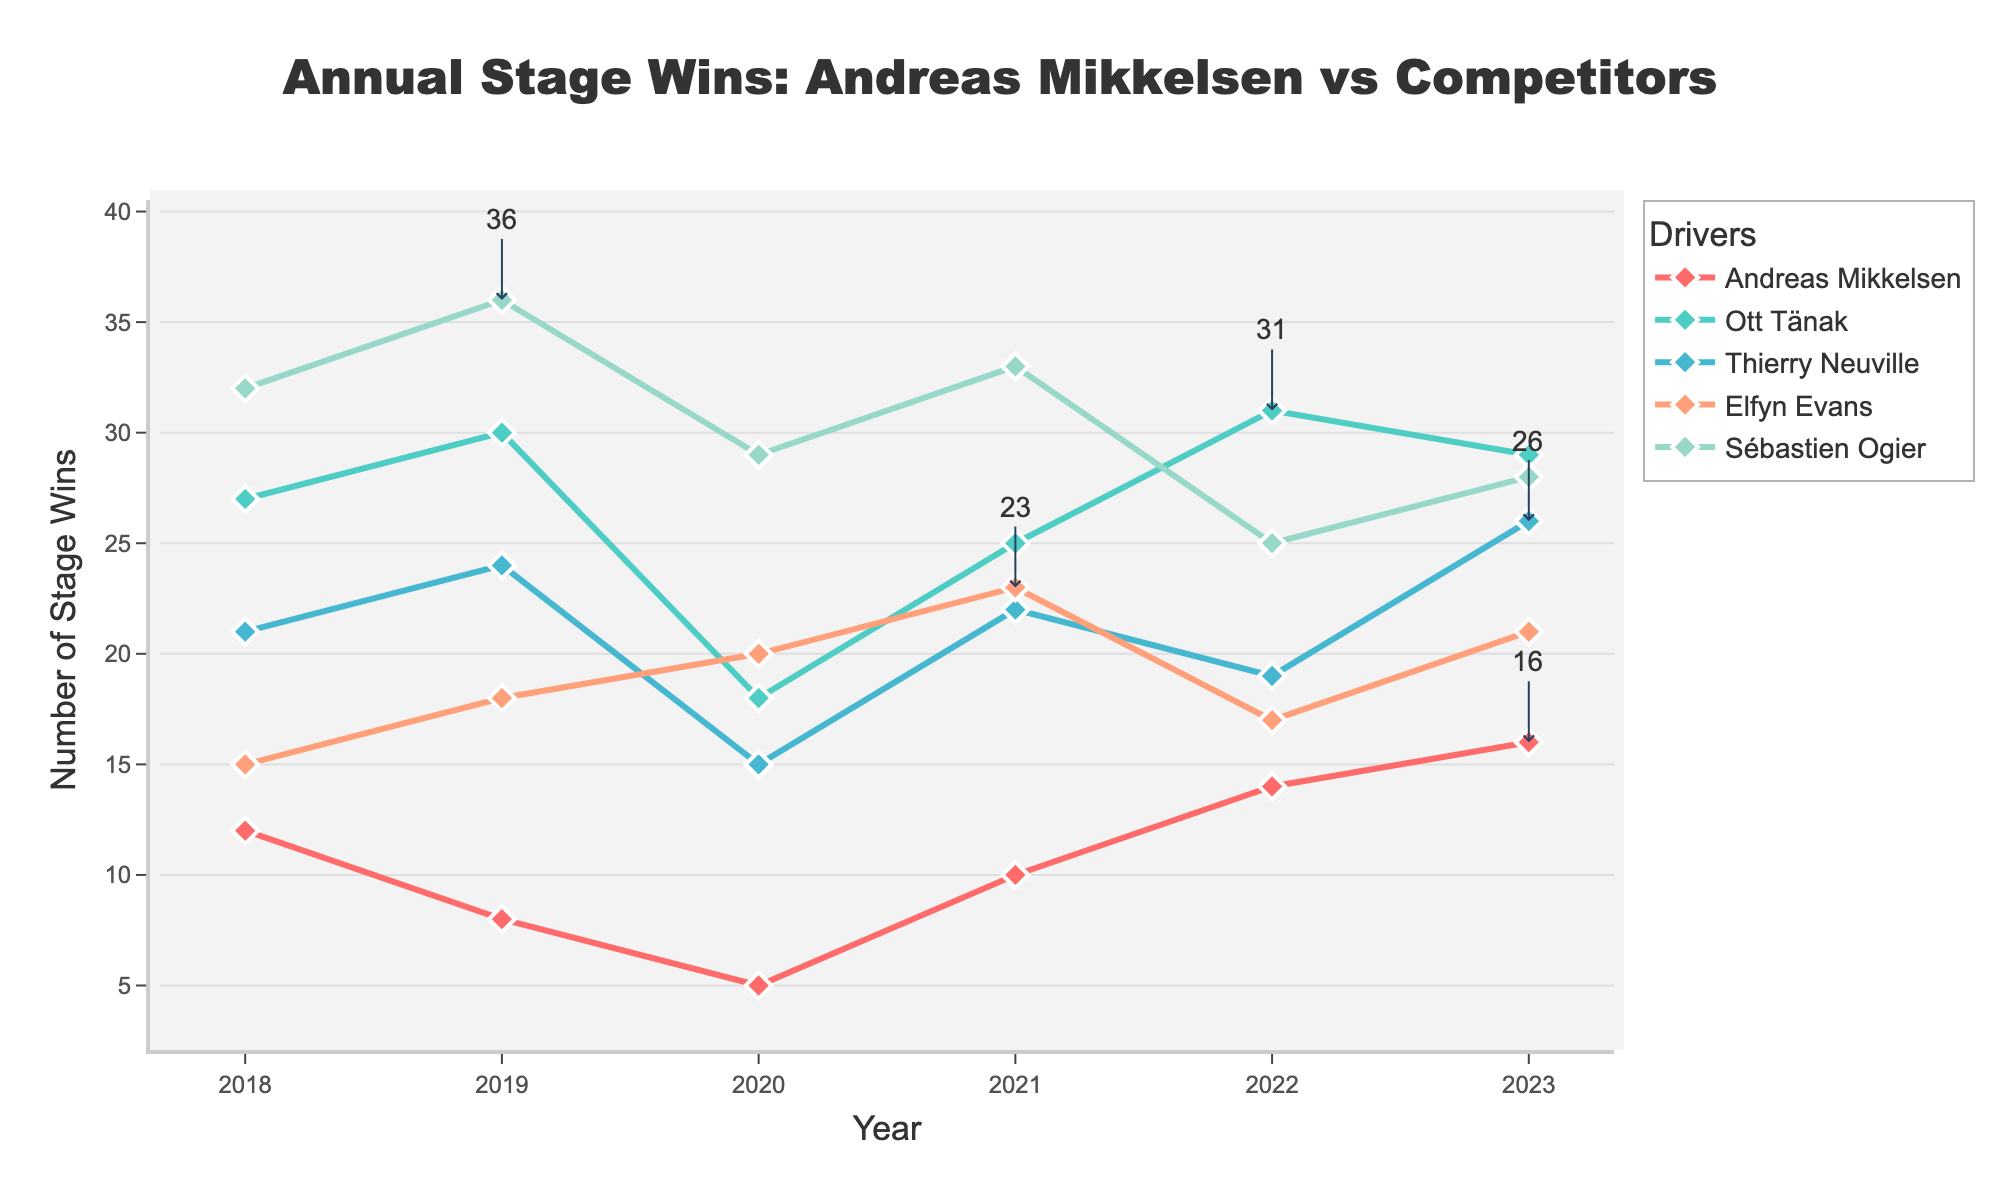what is the total number of stage wins for Andreas Mikkelsen across all years? Add the number of stage wins for each year for Andreas Mikkelsen: 12 (2018) + 8 (2019) + 5 (2020) + 10 (2021) + 14 (2022) + 16 (2023) = 65
Answer: 65 Which year did Ott Tänak have the highest number of stage wins? Look at Ott Tänak's stage wins across the years and identify the highest value. It is 31 in 2022.
Answer: 2022 Did Thierry Neuville have more stage wins in 2020 or 2021? Compare the stage wins for Thierry Neuville in 2020 (15) and 2021 (22). 22 is greater than 15.
Answer: 2021 Which driver had the most stage wins in 2019? Compare the stage wins of all drivers in 2019: Andreas Mikkelsen (8), Ott Tänak (30), Thierry Neuville (24), Elfyn Evans (18), and Sébastien Ogier (36). Sébastien Ogier had the most with 36.
Answer: Sébastien Ogier What's the average number of stage wins for Elfyn Evans from 2018 to 2023? Sum Elfyn Evans' stage wins for each year and then divide by the number of years: (15 + 18 + 20 + 23 + 17 + 21) / 6 = 114 / 6 = 19
Answer: 19 In which year did Andreas Mikkelsen outperform Thierry Neuville? Compare Andreas Mikkelsen and Thierry Neuville's stage wins each year. In 2022, Andreas Mikkelsen (14) had more wins than Thierry Neuville (19).
Answer: 2022 Compare the trend of stage wins between Sébastien Ogier and Ott Tänak from 2018 to 2023. Analyze the data for Sébastien Ogier and Ott Tänak. Sébastien Ogier shows a generally decreasing trend from 2018 (32) to 2023 (28), while Ott Tänak shows a fluctuating trend with no clear increase or decrease.
Answer: Sébastien Ogier generally decreasing, Ott Tänak fluctuating Which driver showed the most improvement in stage wins from 2020 to 2021? Compare the increase in stage wins from 2020 to 2021 for all drivers. Andreas Mikkelsen went from 5 (2020) to 10 (2021), an increase of 5. Ott Tänak increased by 7, Thierry Neuville by 7, Elfyn Evans by 3, and Sébastien Ogier by 4. Thierry Neuville and Ott Tänak had the highest increase of 7.
Answer: Thierry Neuville and Ott Tänak How did the performance of Andreas Mikkelsen in 2023 compare to his performance in 2020? Compare Andreas Mikkelsen's stage wins in 2023 (16) to 2020 (5). He had 11 more wins in 2023.
Answer: Improved (16 vs. 5) 